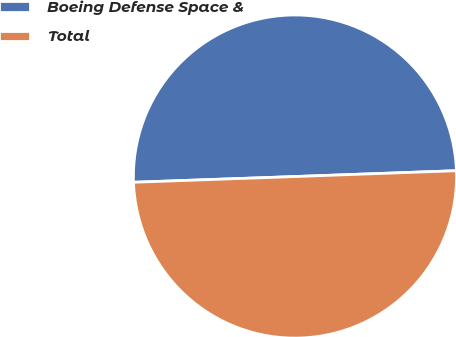Convert chart to OTSL. <chart><loc_0><loc_0><loc_500><loc_500><pie_chart><fcel>Boeing Defense Space &<fcel>Total<nl><fcel>49.99%<fcel>50.01%<nl></chart> 